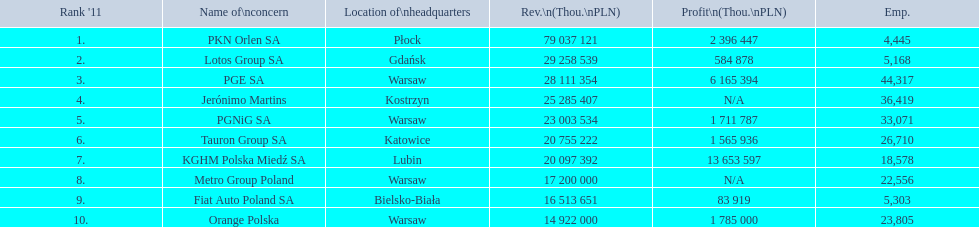What companies are listed? PKN Orlen SA, Lotos Group SA, PGE SA, Jerónimo Martins, PGNiG SA, Tauron Group SA, KGHM Polska Miedź SA, Metro Group Poland, Fiat Auto Poland SA, Orange Polska. What are the company's revenues? 79 037 121, 29 258 539, 28 111 354, 25 285 407, 23 003 534, 20 755 222, 20 097 392, 17 200 000, 16 513 651, 14 922 000. Which company has the greatest revenue? PKN Orlen SA. 